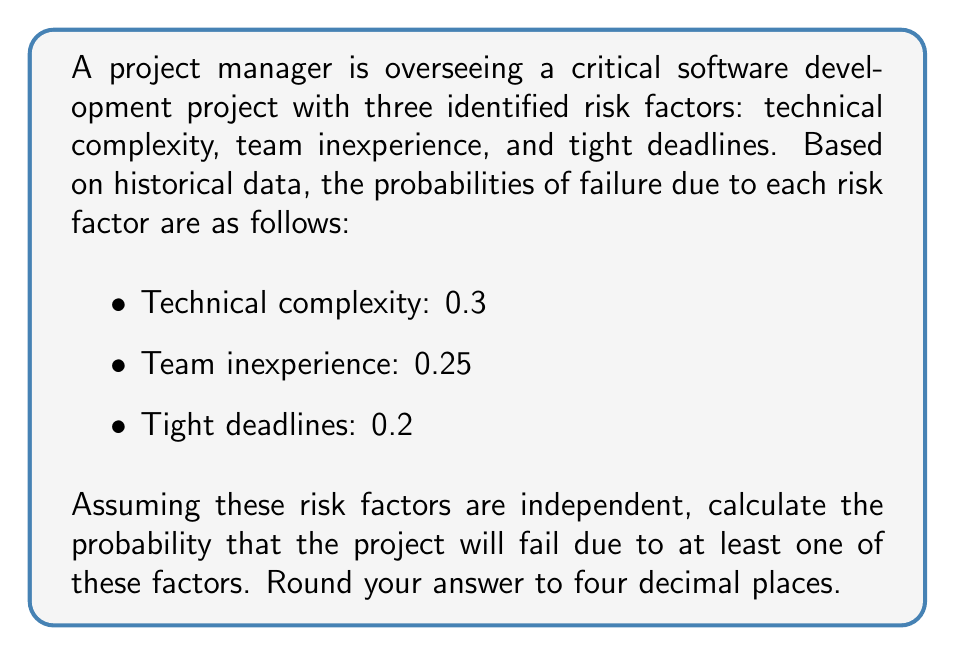Solve this math problem. To solve this problem, we'll use the concept of probability of the union of events. Since we're dealing with independent events, we can use the following approach:

1. Calculate the probability of success for each risk factor:
   - Technical complexity: $P(\text{success}_1) = 1 - 0.3 = 0.7$
   - Team inexperience: $P(\text{success}_2) = 1 - 0.25 = 0.75$
   - Tight deadlines: $P(\text{success}_3) = 1 - 0.2 = 0.8$

2. Calculate the probability of overall success (no failure due to any factor):
   $$P(\text{overall success}) = P(\text{success}_1) \times P(\text{success}_2) \times P(\text{success}_3)$$
   $$P(\text{overall success}) = 0.7 \times 0.75 \times 0.8 = 0.42$$

3. Calculate the probability of failure (at least one risk factor causing failure):
   $$P(\text{failure}) = 1 - P(\text{overall success})$$
   $$P(\text{failure}) = 1 - 0.42 = 0.58$$

4. Round the result to four decimal places:
   $$P(\text{failure}) = 0.5800$$

This approach is based on the principle that the probability of at least one event occurring is equal to 1 minus the probability of none of the events occurring.
Answer: 0.5800 